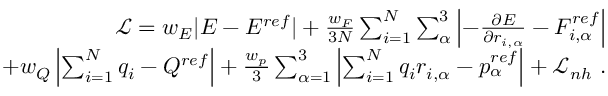Convert formula to latex. <formula><loc_0><loc_0><loc_500><loc_500>\begin{array} { r } { \mathcal { L } = w _ { E } | E - E ^ { r e f } | + \frac { w _ { F } } { 3 N } \sum _ { i = 1 } ^ { N } \sum _ { \alpha } ^ { 3 } \left | - \frac { \partial E } { \partial r _ { i , \alpha } } - F _ { i , \alpha } ^ { r e f } \right | } \\ { + w _ { Q } \left | \sum _ { i = 1 } ^ { N } q _ { i } - Q ^ { r e f } \right | + \frac { w _ { p } } { 3 } \sum _ { \alpha = 1 } ^ { 3 } \left | \sum _ { i = 1 } ^ { N } q _ { i } r _ { i , \alpha } - p _ { \alpha } ^ { r e f } \right | + \mathcal { L } _ { n h } . } \end{array}</formula> 